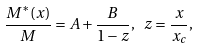<formula> <loc_0><loc_0><loc_500><loc_500>\frac { M ^ { * } ( x ) } { M } = A + \frac { B } { 1 - z } , \ z = \frac { x } { x _ { c } } ,</formula> 